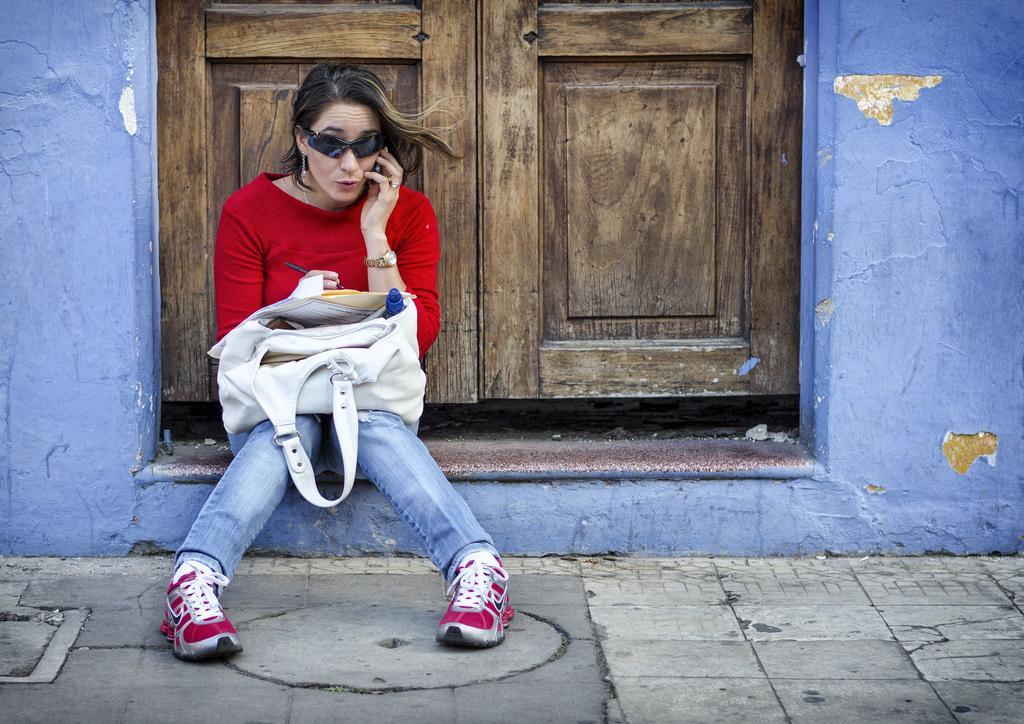Can you describe this image briefly? This image is taken outdoors. At the bottom of the image there is a floor. In the background there is a wall with a door. In the middle of the image a woman is sitting on the floor and she is talking on the floor and she is talking on the phone. 